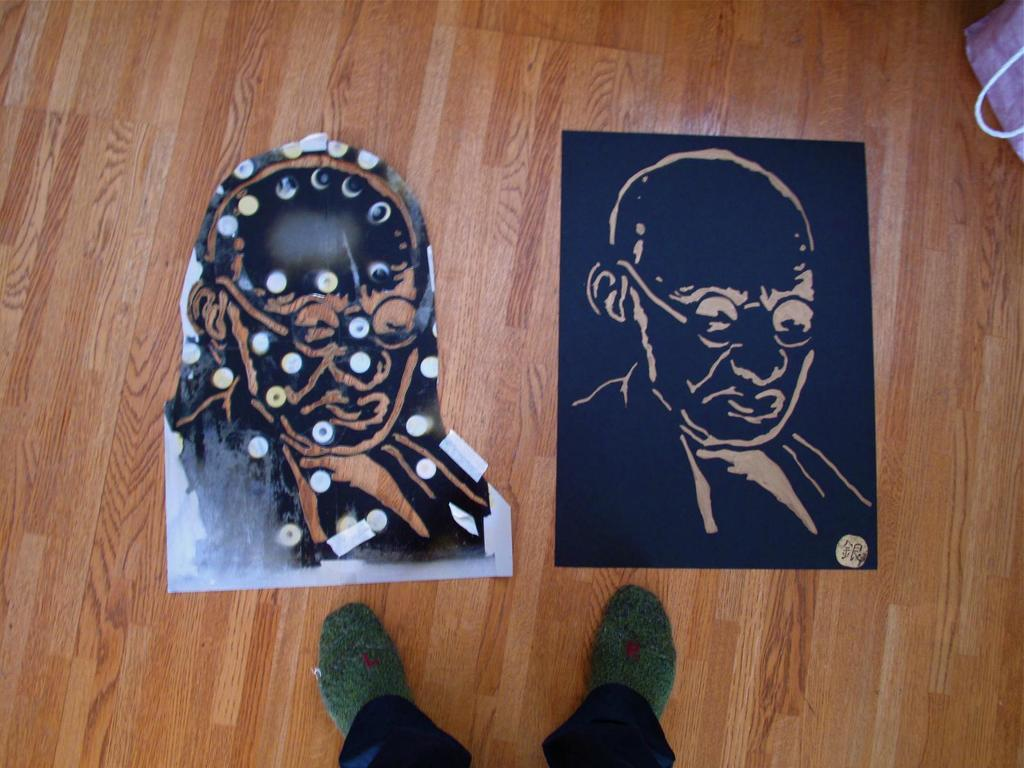What can be seen hanging on the walls in the image? There are two paintings in the image. What type of flooring is present in the image? There is a wooden floor at the bottom of the image. Whose legs are visible in the image? A person's legs are visible at the bottom of the image. Where is the bag located in the image? There is a bag at the top right corner of the image. What type of development can be seen taking place in the harbor in the image? There is no harbor or development present in the image; it features two paintings, a wooden floor, a person's legs, and a bag. What kind of plastic materials are visible in the image? There are no plastic materials visible in the image. 